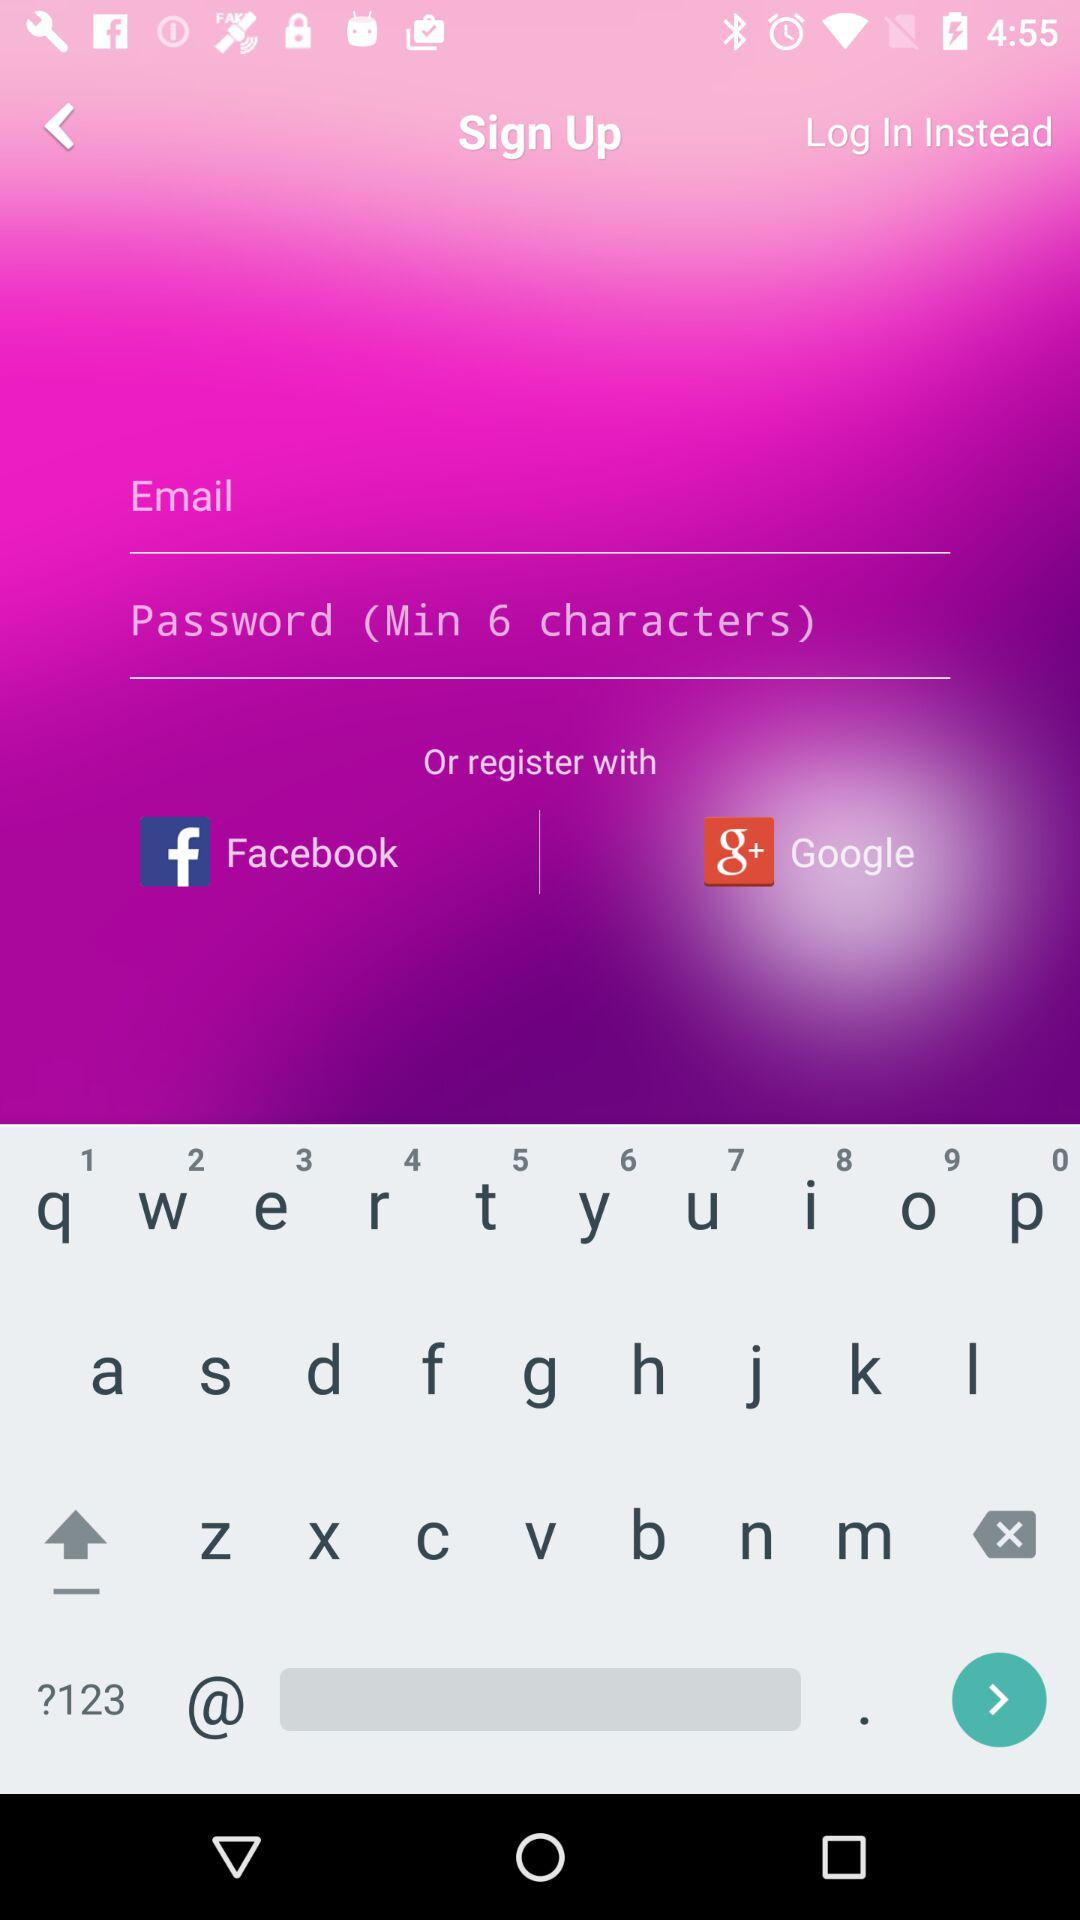How many fields are required to sign up?
Answer the question using a single word or phrase. 2 